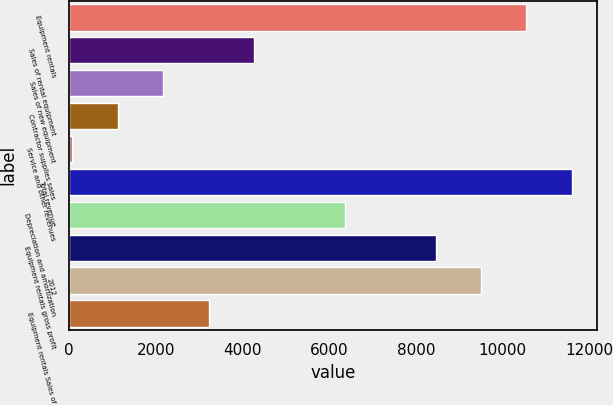Convert chart. <chart><loc_0><loc_0><loc_500><loc_500><bar_chart><fcel>Equipment rentals<fcel>Sales of rental equipment<fcel>Sales of new equipment<fcel>Contractor supplies sales<fcel>Service and other revenues<fcel>Total revenue<fcel>Depreciation and amortization<fcel>Equipment rentals gross profit<fcel>2012<fcel>Equipment rentals Sales of<nl><fcel>10545<fcel>4261.2<fcel>2166.6<fcel>1119.3<fcel>72<fcel>11592.3<fcel>6355.8<fcel>8450.4<fcel>9497.7<fcel>3213.9<nl></chart> 